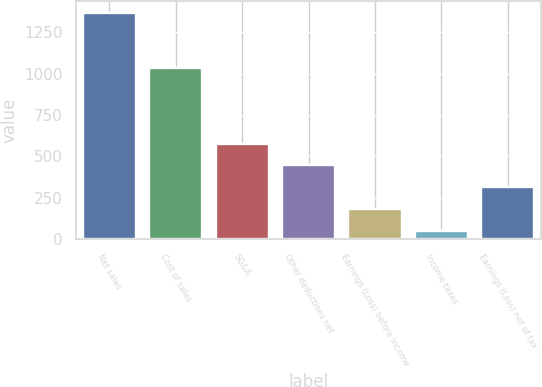Convert chart to OTSL. <chart><loc_0><loc_0><loc_500><loc_500><bar_chart><fcel>Net sales<fcel>Cost of sales<fcel>SG&A<fcel>Other deductions net<fcel>Earnings (Loss) before income<fcel>Income taxes<fcel>Earnings (Loss) net of tax<nl><fcel>1368<fcel>1033<fcel>577.8<fcel>446.1<fcel>182.7<fcel>51<fcel>314.4<nl></chart> 